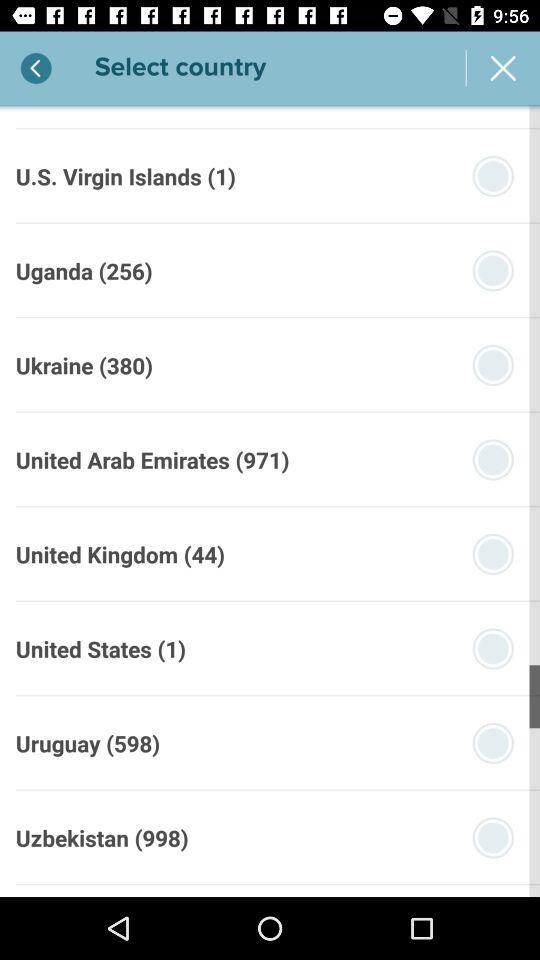Which is the code for the United Kingdom? The code for the United Kingdom is 44. 